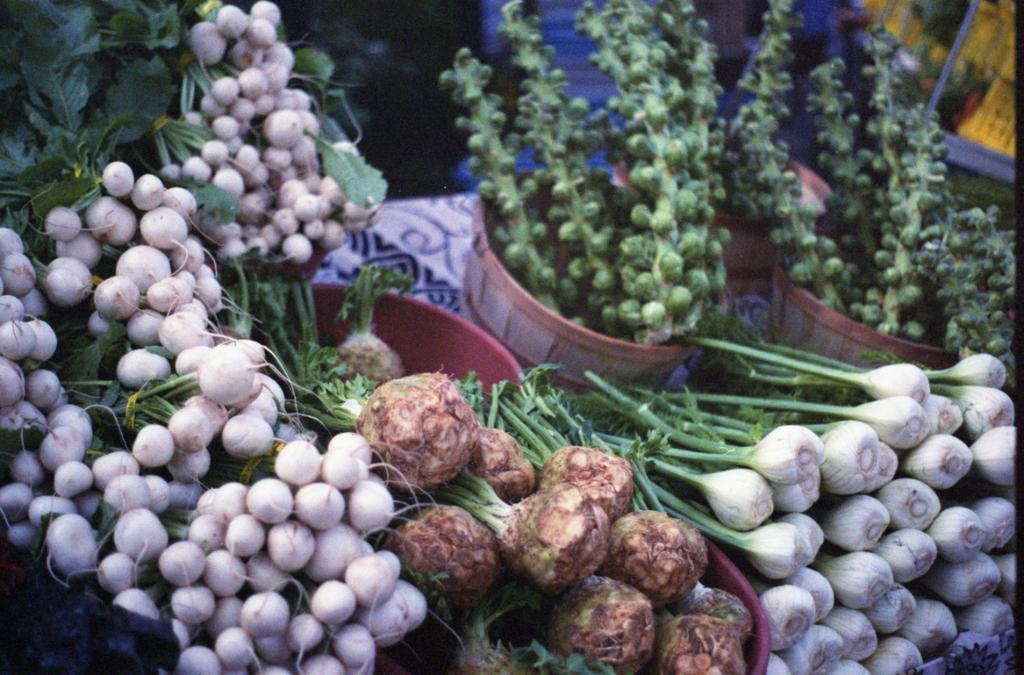Please provide a concise description of this image. In this picture we can see vegetables in the baskets. 